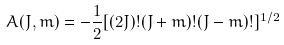<formula> <loc_0><loc_0><loc_500><loc_500>A ( J , m ) = - \frac { 1 } { 2 } [ ( 2 J ) ! ( J + m ) ! ( J - m ) ! ] ^ { 1 / 2 }</formula> 